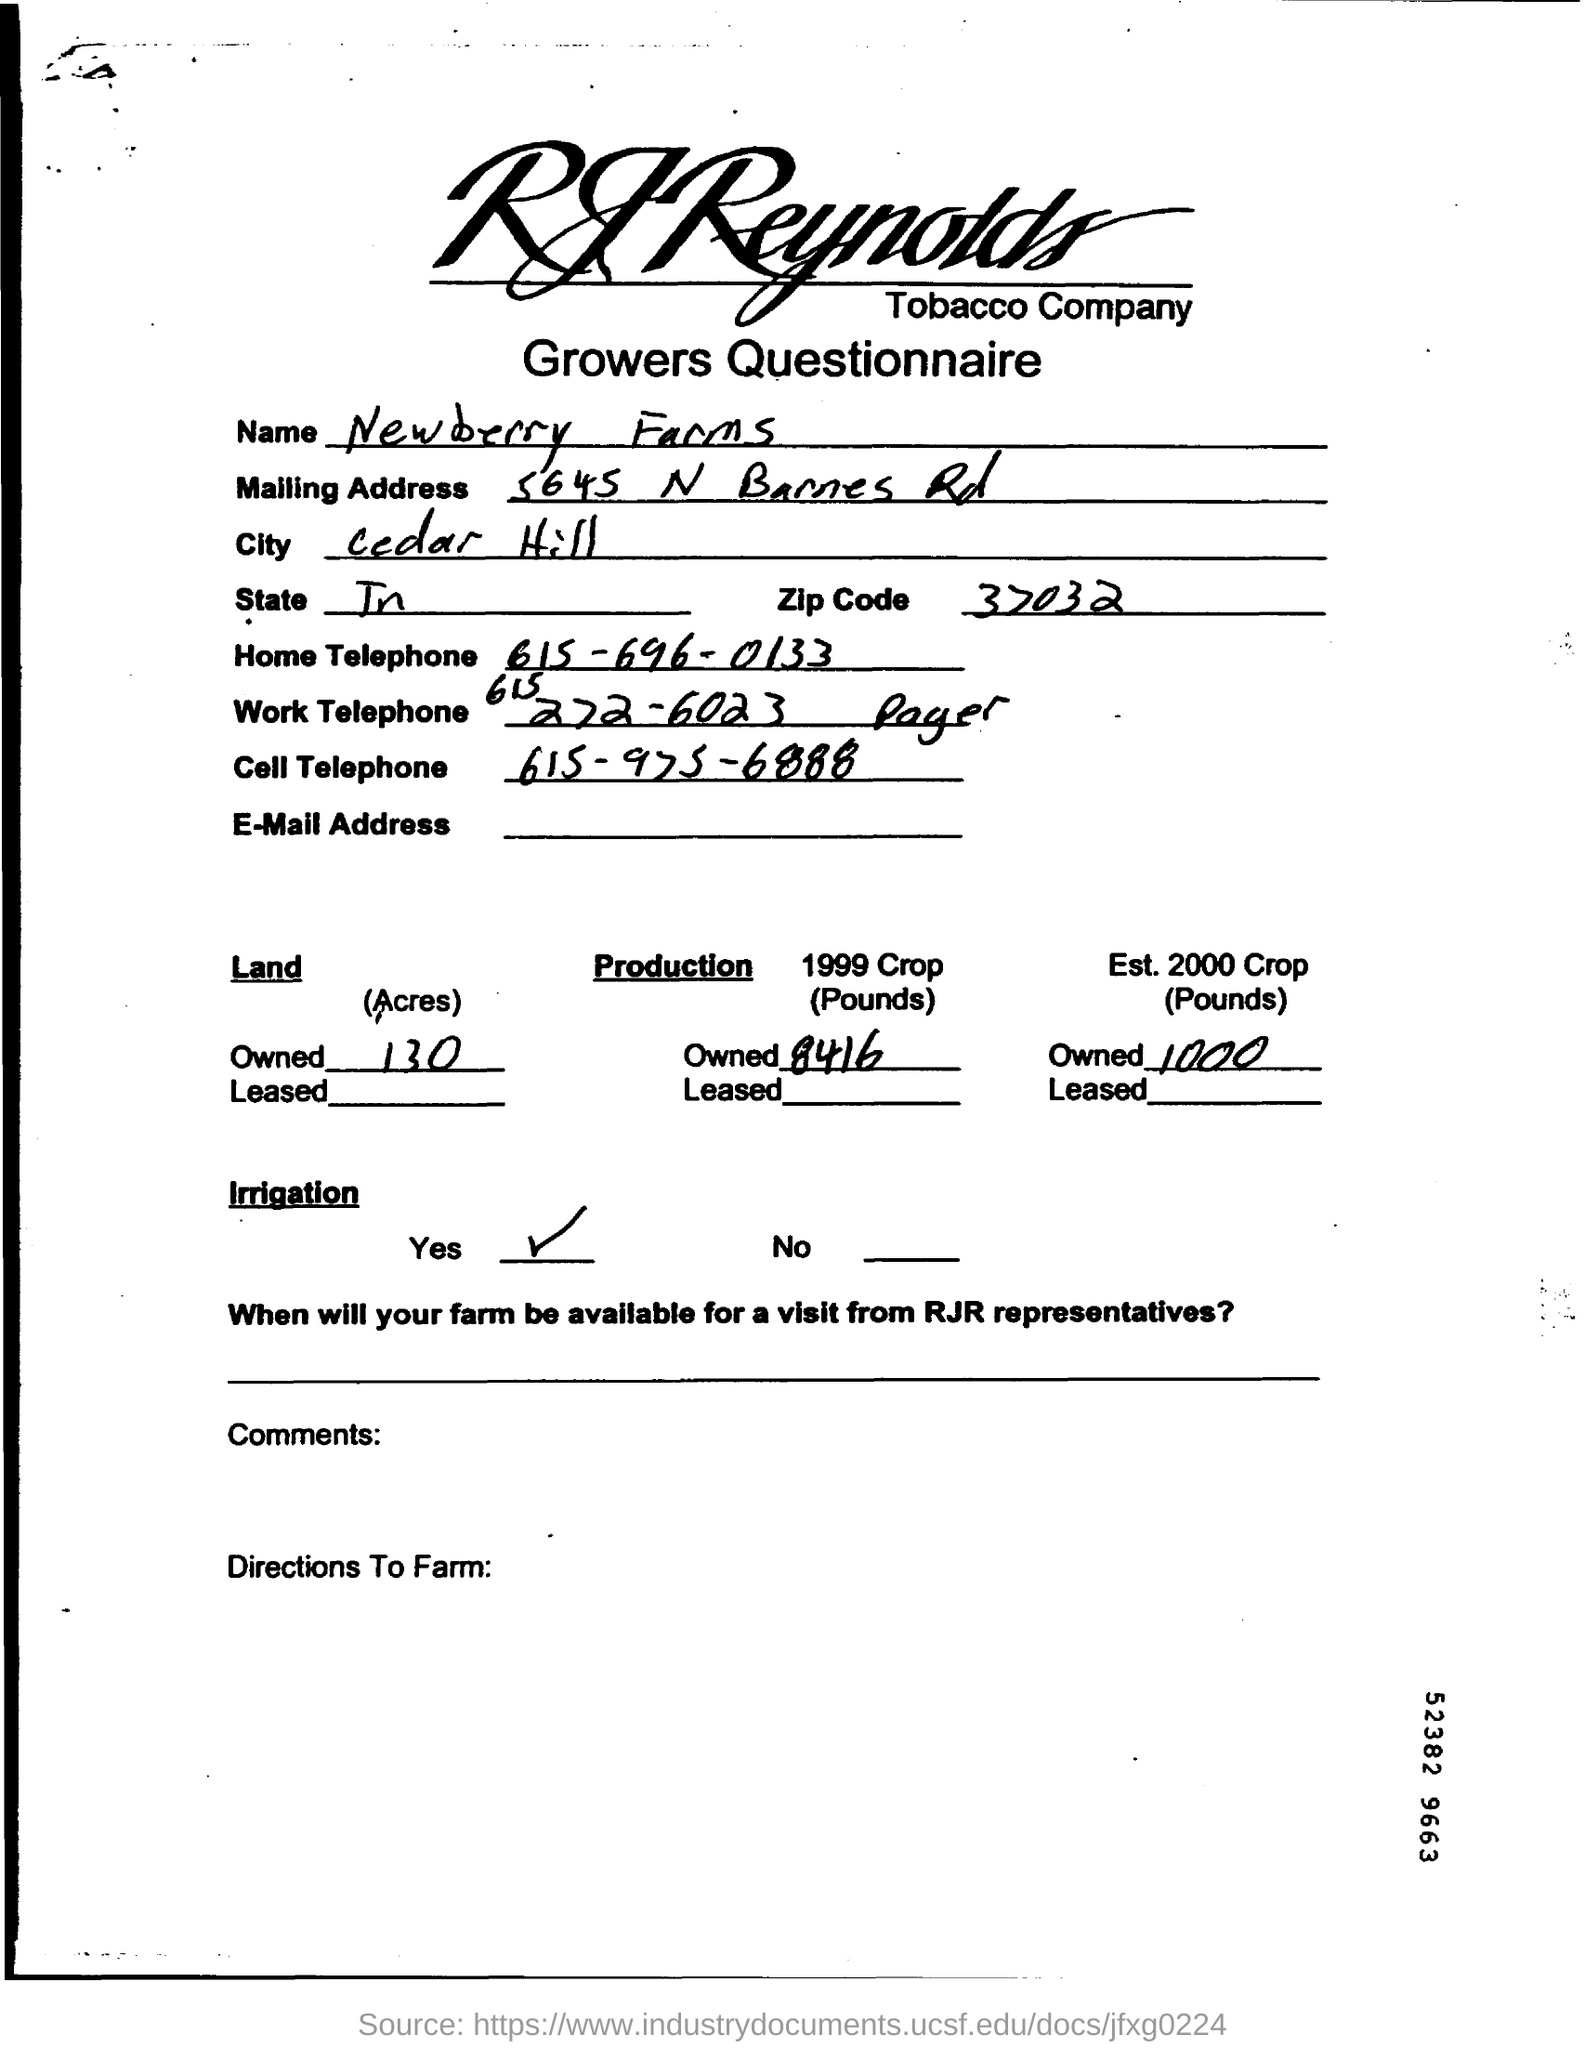Specify some key components in this picture. The city whose name is Cedar Hill is the subject of the sentence. The zip code is 37032. Newberry Farms is the name of the location. 